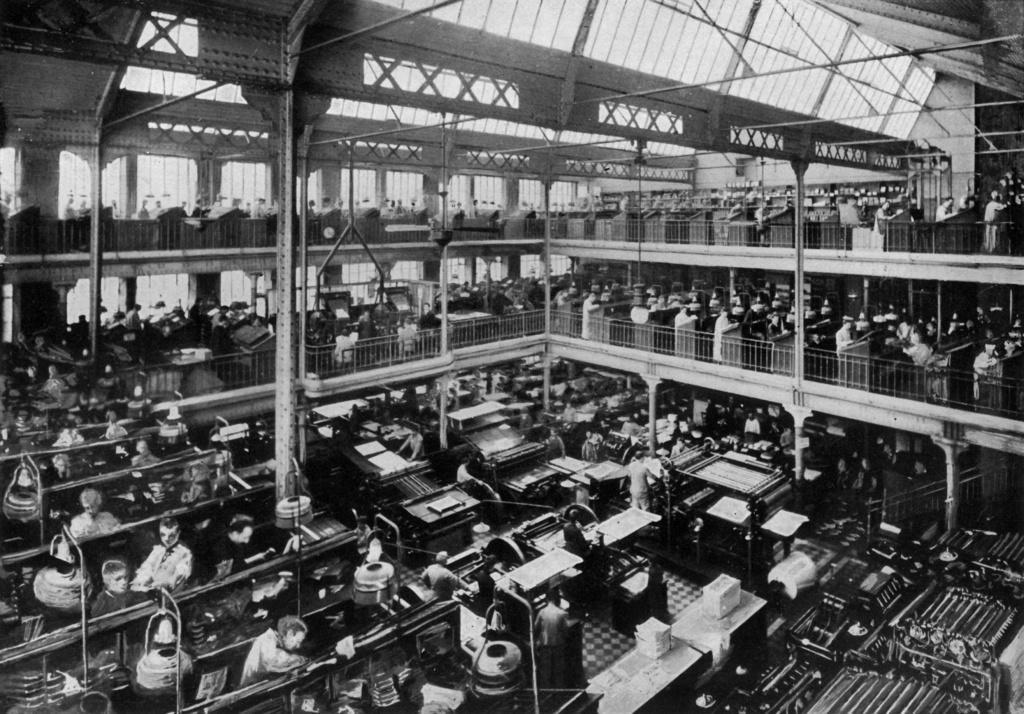Can you describe this image briefly? This picture shows an inner view of a big hall and we see few machines and few people are standing and working on the machines. 